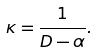Convert formula to latex. <formula><loc_0><loc_0><loc_500><loc_500>\kappa = \frac { 1 } { D - \alpha } .</formula> 